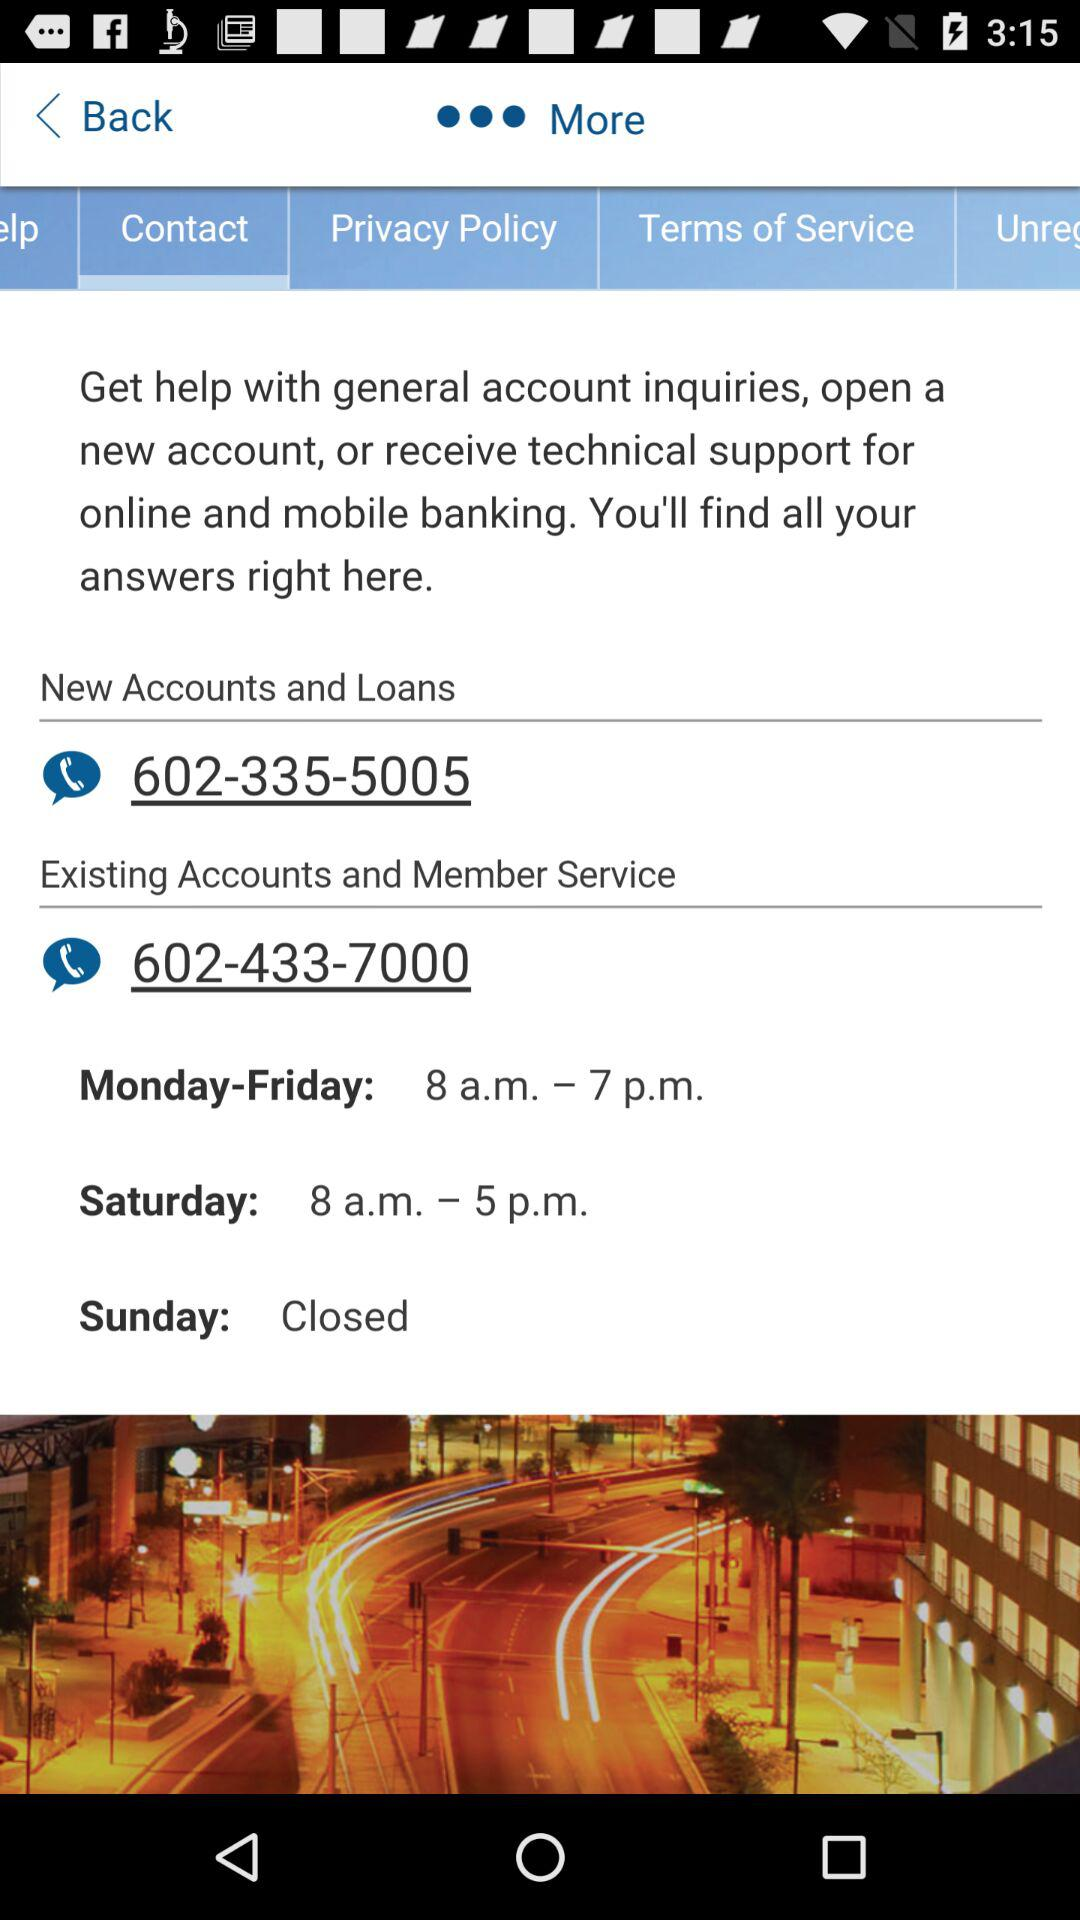How many phone numbers are provided on the help screen?
Answer the question using a single word or phrase. 2 